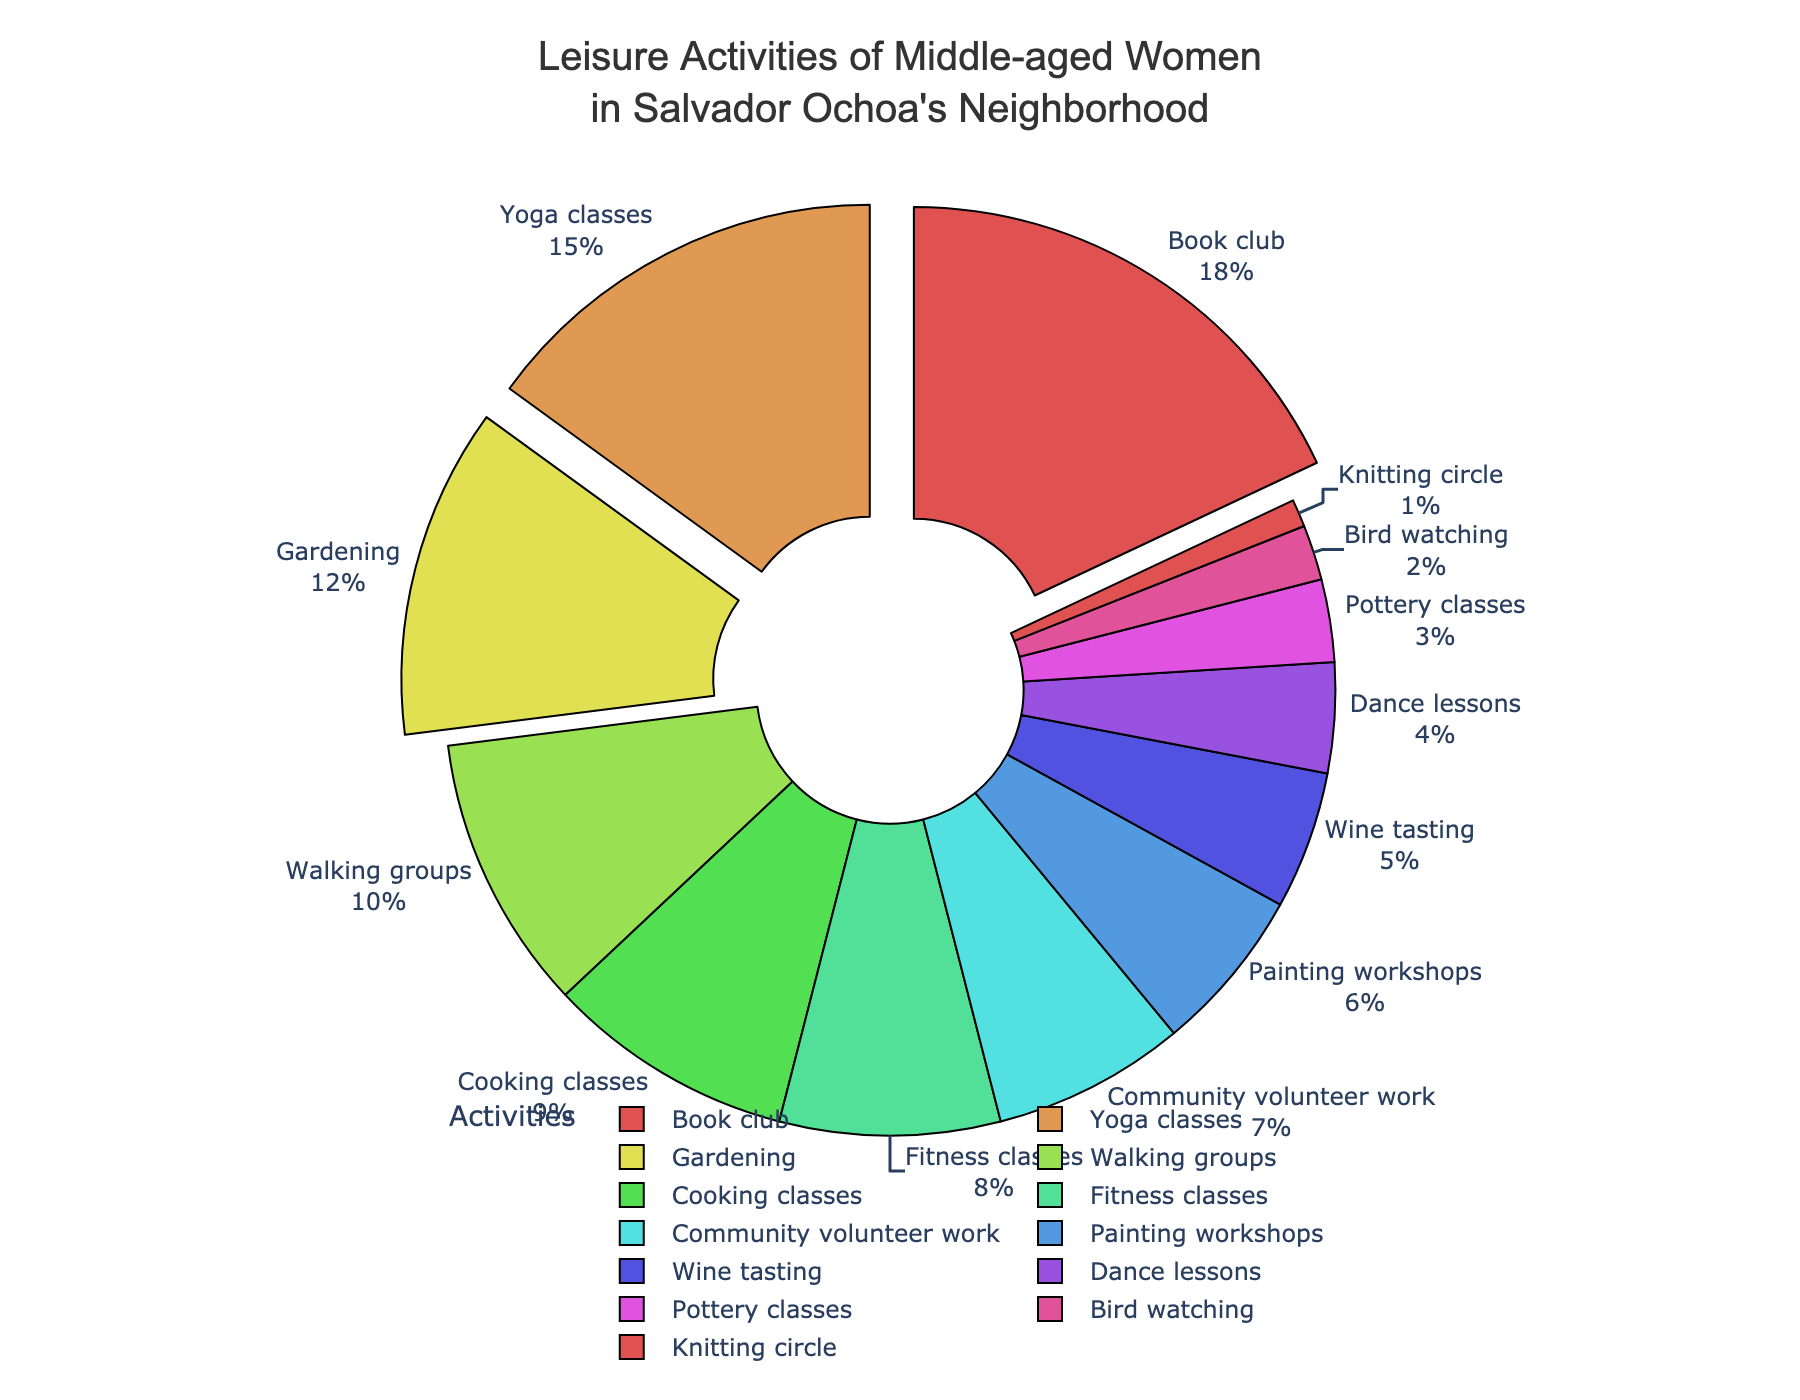What is the most popular leisure activity among middle-aged women in Salvador Ochoa's neighborhood? Find the activity with the highest percentage from the pie chart.
Answer: Book club Which three activities are pulled out from the pie chart? Identify which slices are slightly separated from the pie chart. These typically denote the top activities.
Answer: Book club, Yoga classes, Gardening What is the least popular activity according to the pie chart? Look for the activity with the smallest percentage.
Answer: Knitting circle How much more popular is Book club compared to Yoga classes in percentage points? Subtract the percentage of Yoga classes from that of Book club. 18% - 15% = 3%
Answer: 3% If you combine the percentages of Cooking classes and Fitness classes, how do they compare to Book club? Add the percentages of Cooking classes and Fitness classes, then compare the sum to the percentage of Book club. 9% + 8% = 17%, which is 1% less than Book club's 18%.
Answer: They are 1% less than Book club Which activity has the lowest percentage in the top half of the activities ranked by popularity? Sort activities by percentage in descending order, find the midpoint, and identify the activity with the lowest percentage in the top half. The top half comprises Book club, Yoga classes, Gardening, Walking groups, and Cooking classes. The lowest in this group is Cooking classes.
Answer: Cooking classes How many activities have a percentage lower than Community volunteer work? Identify activities with a percentage lower than that of Community volunteer work (7%). Pottery classes, Bird watching, and Knitting circle all have lower percentages.
Answer: 3 activities Arrange the activities with percentages between 5% and 10% in ascending order. List the activities within this range and arrange them from the lowest to highest percentage. They are: Wine tasting (5%), Community volunteer work (7%), Fitness classes (8%), Cooking classes (9%).
Answer: Wine tasting, Community volunteer work, Fitness classes, Cooking classes Which activity has a higher percentage: Painting workshops or Dance lessons? Compare the percentages of Painting workshops (6%) and Dance lessons (4%).
Answer: Painting workshops 